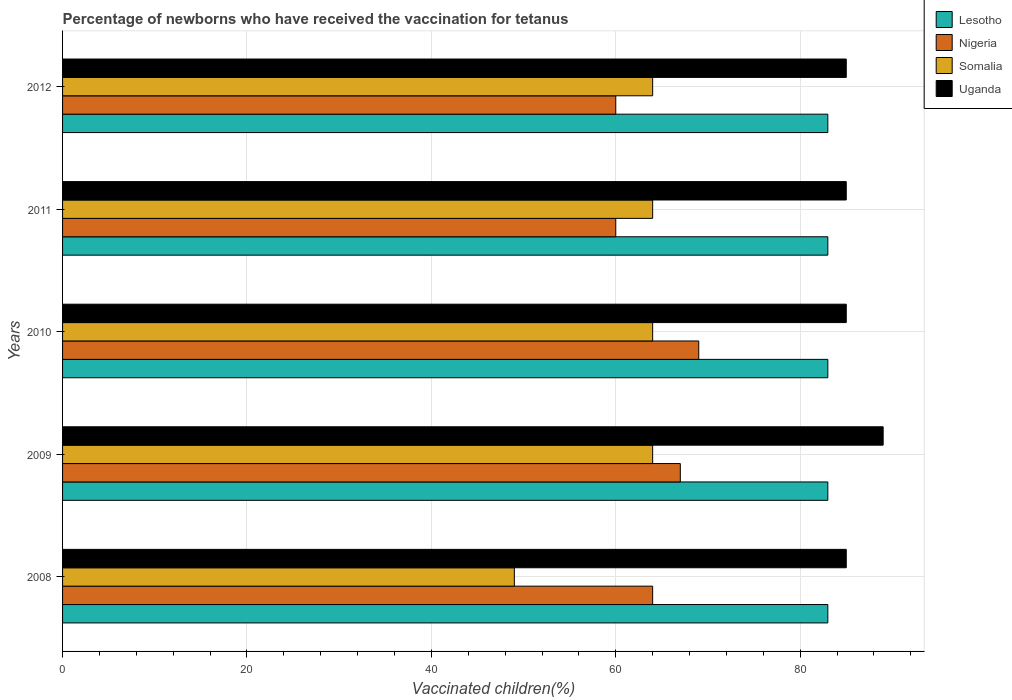How many different coloured bars are there?
Keep it short and to the point. 4. How many groups of bars are there?
Provide a short and direct response. 5. Are the number of bars per tick equal to the number of legend labels?
Keep it short and to the point. Yes. How many bars are there on the 1st tick from the bottom?
Provide a short and direct response. 4. What is the label of the 2nd group of bars from the top?
Provide a short and direct response. 2011. In how many cases, is the number of bars for a given year not equal to the number of legend labels?
Provide a succinct answer. 0. Across all years, what is the maximum percentage of vaccinated children in Uganda?
Give a very brief answer. 89. Across all years, what is the minimum percentage of vaccinated children in Lesotho?
Keep it short and to the point. 83. In which year was the percentage of vaccinated children in Nigeria maximum?
Give a very brief answer. 2010. In which year was the percentage of vaccinated children in Lesotho minimum?
Provide a short and direct response. 2008. What is the total percentage of vaccinated children in Nigeria in the graph?
Offer a very short reply. 320. What is the average percentage of vaccinated children in Uganda per year?
Offer a very short reply. 85.8. In the year 2008, what is the difference between the percentage of vaccinated children in Lesotho and percentage of vaccinated children in Uganda?
Provide a succinct answer. -2. In how many years, is the percentage of vaccinated children in Nigeria greater than 20 %?
Your answer should be compact. 5. Is the percentage of vaccinated children in Somalia in 2008 less than that in 2011?
Give a very brief answer. Yes. What is the difference between the highest and the second highest percentage of vaccinated children in Lesotho?
Provide a short and direct response. 0. What is the difference between the highest and the lowest percentage of vaccinated children in Uganda?
Provide a short and direct response. 4. In how many years, is the percentage of vaccinated children in Lesotho greater than the average percentage of vaccinated children in Lesotho taken over all years?
Your response must be concise. 0. Is the sum of the percentage of vaccinated children in Lesotho in 2008 and 2010 greater than the maximum percentage of vaccinated children in Somalia across all years?
Your response must be concise. Yes. What does the 4th bar from the top in 2009 represents?
Ensure brevity in your answer.  Lesotho. What does the 2nd bar from the bottom in 2011 represents?
Provide a succinct answer. Nigeria. Is it the case that in every year, the sum of the percentage of vaccinated children in Somalia and percentage of vaccinated children in Lesotho is greater than the percentage of vaccinated children in Nigeria?
Your answer should be compact. Yes. Are all the bars in the graph horizontal?
Provide a short and direct response. Yes. How many legend labels are there?
Make the answer very short. 4. How are the legend labels stacked?
Your response must be concise. Vertical. What is the title of the graph?
Keep it short and to the point. Percentage of newborns who have received the vaccination for tetanus. What is the label or title of the X-axis?
Your response must be concise. Vaccinated children(%). What is the Vaccinated children(%) of Nigeria in 2008?
Keep it short and to the point. 64. What is the Vaccinated children(%) of Uganda in 2008?
Offer a very short reply. 85. What is the Vaccinated children(%) of Lesotho in 2009?
Make the answer very short. 83. What is the Vaccinated children(%) of Nigeria in 2009?
Give a very brief answer. 67. What is the Vaccinated children(%) of Uganda in 2009?
Your response must be concise. 89. What is the Vaccinated children(%) of Lesotho in 2010?
Provide a succinct answer. 83. What is the Vaccinated children(%) of Nigeria in 2010?
Ensure brevity in your answer.  69. What is the Vaccinated children(%) in Uganda in 2010?
Offer a very short reply. 85. What is the Vaccinated children(%) of Lesotho in 2011?
Your response must be concise. 83. What is the Vaccinated children(%) of Nigeria in 2011?
Ensure brevity in your answer.  60. What is the Vaccinated children(%) of Somalia in 2011?
Provide a short and direct response. 64. What is the Vaccinated children(%) of Nigeria in 2012?
Your answer should be compact. 60. What is the Vaccinated children(%) of Somalia in 2012?
Keep it short and to the point. 64. Across all years, what is the maximum Vaccinated children(%) in Lesotho?
Your answer should be very brief. 83. Across all years, what is the maximum Vaccinated children(%) in Nigeria?
Ensure brevity in your answer.  69. Across all years, what is the maximum Vaccinated children(%) of Uganda?
Offer a terse response. 89. Across all years, what is the minimum Vaccinated children(%) in Nigeria?
Provide a succinct answer. 60. What is the total Vaccinated children(%) of Lesotho in the graph?
Ensure brevity in your answer.  415. What is the total Vaccinated children(%) in Nigeria in the graph?
Your response must be concise. 320. What is the total Vaccinated children(%) of Somalia in the graph?
Provide a succinct answer. 305. What is the total Vaccinated children(%) of Uganda in the graph?
Provide a succinct answer. 429. What is the difference between the Vaccinated children(%) in Somalia in 2008 and that in 2009?
Offer a very short reply. -15. What is the difference between the Vaccinated children(%) in Lesotho in 2008 and that in 2010?
Keep it short and to the point. 0. What is the difference between the Vaccinated children(%) of Nigeria in 2008 and that in 2010?
Give a very brief answer. -5. What is the difference between the Vaccinated children(%) of Somalia in 2008 and that in 2010?
Provide a succinct answer. -15. What is the difference between the Vaccinated children(%) of Uganda in 2008 and that in 2010?
Provide a succinct answer. 0. What is the difference between the Vaccinated children(%) in Lesotho in 2008 and that in 2011?
Give a very brief answer. 0. What is the difference between the Vaccinated children(%) of Uganda in 2008 and that in 2011?
Ensure brevity in your answer.  0. What is the difference between the Vaccinated children(%) of Lesotho in 2008 and that in 2012?
Make the answer very short. 0. What is the difference between the Vaccinated children(%) in Somalia in 2008 and that in 2012?
Give a very brief answer. -15. What is the difference between the Vaccinated children(%) of Uganda in 2008 and that in 2012?
Make the answer very short. 0. What is the difference between the Vaccinated children(%) in Lesotho in 2009 and that in 2010?
Ensure brevity in your answer.  0. What is the difference between the Vaccinated children(%) in Somalia in 2009 and that in 2011?
Keep it short and to the point. 0. What is the difference between the Vaccinated children(%) of Uganda in 2009 and that in 2011?
Your answer should be compact. 4. What is the difference between the Vaccinated children(%) of Nigeria in 2009 and that in 2012?
Offer a very short reply. 7. What is the difference between the Vaccinated children(%) of Uganda in 2009 and that in 2012?
Provide a succinct answer. 4. What is the difference between the Vaccinated children(%) of Lesotho in 2010 and that in 2011?
Make the answer very short. 0. What is the difference between the Vaccinated children(%) of Nigeria in 2010 and that in 2011?
Your response must be concise. 9. What is the difference between the Vaccinated children(%) in Lesotho in 2010 and that in 2012?
Make the answer very short. 0. What is the difference between the Vaccinated children(%) of Nigeria in 2010 and that in 2012?
Provide a short and direct response. 9. What is the difference between the Vaccinated children(%) in Somalia in 2010 and that in 2012?
Your response must be concise. 0. What is the difference between the Vaccinated children(%) of Uganda in 2010 and that in 2012?
Your response must be concise. 0. What is the difference between the Vaccinated children(%) in Nigeria in 2011 and that in 2012?
Provide a succinct answer. 0. What is the difference between the Vaccinated children(%) in Somalia in 2011 and that in 2012?
Make the answer very short. 0. What is the difference between the Vaccinated children(%) of Lesotho in 2008 and the Vaccinated children(%) of Nigeria in 2009?
Give a very brief answer. 16. What is the difference between the Vaccinated children(%) in Lesotho in 2008 and the Vaccinated children(%) in Somalia in 2009?
Ensure brevity in your answer.  19. What is the difference between the Vaccinated children(%) in Lesotho in 2008 and the Vaccinated children(%) in Uganda in 2009?
Your answer should be compact. -6. What is the difference between the Vaccinated children(%) in Nigeria in 2008 and the Vaccinated children(%) in Somalia in 2009?
Offer a very short reply. 0. What is the difference between the Vaccinated children(%) of Nigeria in 2008 and the Vaccinated children(%) of Uganda in 2010?
Make the answer very short. -21. What is the difference between the Vaccinated children(%) of Somalia in 2008 and the Vaccinated children(%) of Uganda in 2010?
Your answer should be compact. -36. What is the difference between the Vaccinated children(%) in Lesotho in 2008 and the Vaccinated children(%) in Uganda in 2011?
Offer a very short reply. -2. What is the difference between the Vaccinated children(%) of Nigeria in 2008 and the Vaccinated children(%) of Uganda in 2011?
Provide a succinct answer. -21. What is the difference between the Vaccinated children(%) of Somalia in 2008 and the Vaccinated children(%) of Uganda in 2011?
Your response must be concise. -36. What is the difference between the Vaccinated children(%) of Lesotho in 2008 and the Vaccinated children(%) of Nigeria in 2012?
Your answer should be very brief. 23. What is the difference between the Vaccinated children(%) of Lesotho in 2008 and the Vaccinated children(%) of Uganda in 2012?
Offer a very short reply. -2. What is the difference between the Vaccinated children(%) of Nigeria in 2008 and the Vaccinated children(%) of Somalia in 2012?
Offer a very short reply. 0. What is the difference between the Vaccinated children(%) of Nigeria in 2008 and the Vaccinated children(%) of Uganda in 2012?
Make the answer very short. -21. What is the difference between the Vaccinated children(%) of Somalia in 2008 and the Vaccinated children(%) of Uganda in 2012?
Provide a short and direct response. -36. What is the difference between the Vaccinated children(%) of Lesotho in 2009 and the Vaccinated children(%) of Nigeria in 2010?
Your answer should be very brief. 14. What is the difference between the Vaccinated children(%) of Lesotho in 2009 and the Vaccinated children(%) of Uganda in 2010?
Offer a very short reply. -2. What is the difference between the Vaccinated children(%) of Nigeria in 2009 and the Vaccinated children(%) of Uganda in 2010?
Keep it short and to the point. -18. What is the difference between the Vaccinated children(%) of Lesotho in 2009 and the Vaccinated children(%) of Nigeria in 2011?
Give a very brief answer. 23. What is the difference between the Vaccinated children(%) of Nigeria in 2009 and the Vaccinated children(%) of Somalia in 2011?
Offer a very short reply. 3. What is the difference between the Vaccinated children(%) in Lesotho in 2009 and the Vaccinated children(%) in Somalia in 2012?
Provide a succinct answer. 19. What is the difference between the Vaccinated children(%) of Lesotho in 2009 and the Vaccinated children(%) of Uganda in 2012?
Make the answer very short. -2. What is the difference between the Vaccinated children(%) of Nigeria in 2009 and the Vaccinated children(%) of Somalia in 2012?
Ensure brevity in your answer.  3. What is the difference between the Vaccinated children(%) in Lesotho in 2010 and the Vaccinated children(%) in Nigeria in 2011?
Provide a succinct answer. 23. What is the difference between the Vaccinated children(%) in Somalia in 2010 and the Vaccinated children(%) in Uganda in 2011?
Offer a very short reply. -21. What is the difference between the Vaccinated children(%) of Lesotho in 2010 and the Vaccinated children(%) of Somalia in 2012?
Make the answer very short. 19. What is the difference between the Vaccinated children(%) of Nigeria in 2010 and the Vaccinated children(%) of Uganda in 2012?
Provide a short and direct response. -16. What is the difference between the Vaccinated children(%) of Lesotho in 2011 and the Vaccinated children(%) of Somalia in 2012?
Provide a succinct answer. 19. What is the difference between the Vaccinated children(%) in Nigeria in 2011 and the Vaccinated children(%) in Somalia in 2012?
Provide a short and direct response. -4. What is the average Vaccinated children(%) in Lesotho per year?
Offer a very short reply. 83. What is the average Vaccinated children(%) in Uganda per year?
Give a very brief answer. 85.8. In the year 2008, what is the difference between the Vaccinated children(%) of Lesotho and Vaccinated children(%) of Nigeria?
Your response must be concise. 19. In the year 2008, what is the difference between the Vaccinated children(%) in Lesotho and Vaccinated children(%) in Uganda?
Your answer should be very brief. -2. In the year 2008, what is the difference between the Vaccinated children(%) in Somalia and Vaccinated children(%) in Uganda?
Your response must be concise. -36. In the year 2009, what is the difference between the Vaccinated children(%) in Lesotho and Vaccinated children(%) in Somalia?
Offer a very short reply. 19. In the year 2010, what is the difference between the Vaccinated children(%) of Lesotho and Vaccinated children(%) of Nigeria?
Give a very brief answer. 14. In the year 2010, what is the difference between the Vaccinated children(%) of Lesotho and Vaccinated children(%) of Uganda?
Offer a terse response. -2. In the year 2010, what is the difference between the Vaccinated children(%) of Nigeria and Vaccinated children(%) of Uganda?
Provide a short and direct response. -16. In the year 2010, what is the difference between the Vaccinated children(%) in Somalia and Vaccinated children(%) in Uganda?
Keep it short and to the point. -21. In the year 2011, what is the difference between the Vaccinated children(%) of Lesotho and Vaccinated children(%) of Somalia?
Keep it short and to the point. 19. In the year 2011, what is the difference between the Vaccinated children(%) in Lesotho and Vaccinated children(%) in Uganda?
Offer a terse response. -2. In the year 2011, what is the difference between the Vaccinated children(%) of Nigeria and Vaccinated children(%) of Somalia?
Your response must be concise. -4. In the year 2011, what is the difference between the Vaccinated children(%) in Somalia and Vaccinated children(%) in Uganda?
Make the answer very short. -21. In the year 2012, what is the difference between the Vaccinated children(%) in Lesotho and Vaccinated children(%) in Somalia?
Your response must be concise. 19. In the year 2012, what is the difference between the Vaccinated children(%) of Lesotho and Vaccinated children(%) of Uganda?
Provide a short and direct response. -2. In the year 2012, what is the difference between the Vaccinated children(%) of Nigeria and Vaccinated children(%) of Uganda?
Make the answer very short. -25. What is the ratio of the Vaccinated children(%) of Lesotho in 2008 to that in 2009?
Your response must be concise. 1. What is the ratio of the Vaccinated children(%) in Nigeria in 2008 to that in 2009?
Offer a very short reply. 0.96. What is the ratio of the Vaccinated children(%) in Somalia in 2008 to that in 2009?
Offer a terse response. 0.77. What is the ratio of the Vaccinated children(%) in Uganda in 2008 to that in 2009?
Provide a succinct answer. 0.96. What is the ratio of the Vaccinated children(%) of Nigeria in 2008 to that in 2010?
Keep it short and to the point. 0.93. What is the ratio of the Vaccinated children(%) in Somalia in 2008 to that in 2010?
Provide a short and direct response. 0.77. What is the ratio of the Vaccinated children(%) in Nigeria in 2008 to that in 2011?
Offer a very short reply. 1.07. What is the ratio of the Vaccinated children(%) of Somalia in 2008 to that in 2011?
Make the answer very short. 0.77. What is the ratio of the Vaccinated children(%) of Lesotho in 2008 to that in 2012?
Provide a succinct answer. 1. What is the ratio of the Vaccinated children(%) in Nigeria in 2008 to that in 2012?
Give a very brief answer. 1.07. What is the ratio of the Vaccinated children(%) of Somalia in 2008 to that in 2012?
Make the answer very short. 0.77. What is the ratio of the Vaccinated children(%) of Uganda in 2008 to that in 2012?
Give a very brief answer. 1. What is the ratio of the Vaccinated children(%) of Lesotho in 2009 to that in 2010?
Give a very brief answer. 1. What is the ratio of the Vaccinated children(%) in Uganda in 2009 to that in 2010?
Keep it short and to the point. 1.05. What is the ratio of the Vaccinated children(%) in Nigeria in 2009 to that in 2011?
Provide a short and direct response. 1.12. What is the ratio of the Vaccinated children(%) of Uganda in 2009 to that in 2011?
Offer a very short reply. 1.05. What is the ratio of the Vaccinated children(%) in Nigeria in 2009 to that in 2012?
Your response must be concise. 1.12. What is the ratio of the Vaccinated children(%) in Somalia in 2009 to that in 2012?
Ensure brevity in your answer.  1. What is the ratio of the Vaccinated children(%) in Uganda in 2009 to that in 2012?
Offer a very short reply. 1.05. What is the ratio of the Vaccinated children(%) in Nigeria in 2010 to that in 2011?
Make the answer very short. 1.15. What is the ratio of the Vaccinated children(%) of Nigeria in 2010 to that in 2012?
Your response must be concise. 1.15. What is the ratio of the Vaccinated children(%) of Somalia in 2010 to that in 2012?
Provide a succinct answer. 1. What is the ratio of the Vaccinated children(%) of Lesotho in 2011 to that in 2012?
Give a very brief answer. 1. What is the ratio of the Vaccinated children(%) in Nigeria in 2011 to that in 2012?
Your response must be concise. 1. What is the difference between the highest and the second highest Vaccinated children(%) in Nigeria?
Your response must be concise. 2. What is the difference between the highest and the second highest Vaccinated children(%) in Somalia?
Your answer should be compact. 0. What is the difference between the highest and the lowest Vaccinated children(%) in Lesotho?
Ensure brevity in your answer.  0. 